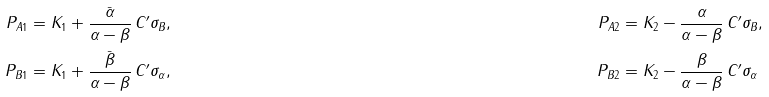<formula> <loc_0><loc_0><loc_500><loc_500>P _ { A 1 } & = K _ { 1 } + \frac { \bar { \alpha } } { \alpha - \beta } \, C ^ { \prime } \sigma _ { B } , & P _ { A 2 } & = K _ { 2 } - \frac { \alpha } { \alpha - \beta } \, C ^ { \prime } \sigma _ { B } , \\ P _ { B 1 } & = K _ { 1 } + \frac { \bar { \beta } } { \alpha - \beta } \, C ^ { \prime } \sigma _ { \alpha } , & P _ { B 2 } & = K _ { 2 } - \frac { \beta } { \alpha - \beta } \, C ^ { \prime } \sigma _ { \alpha } \\</formula> 